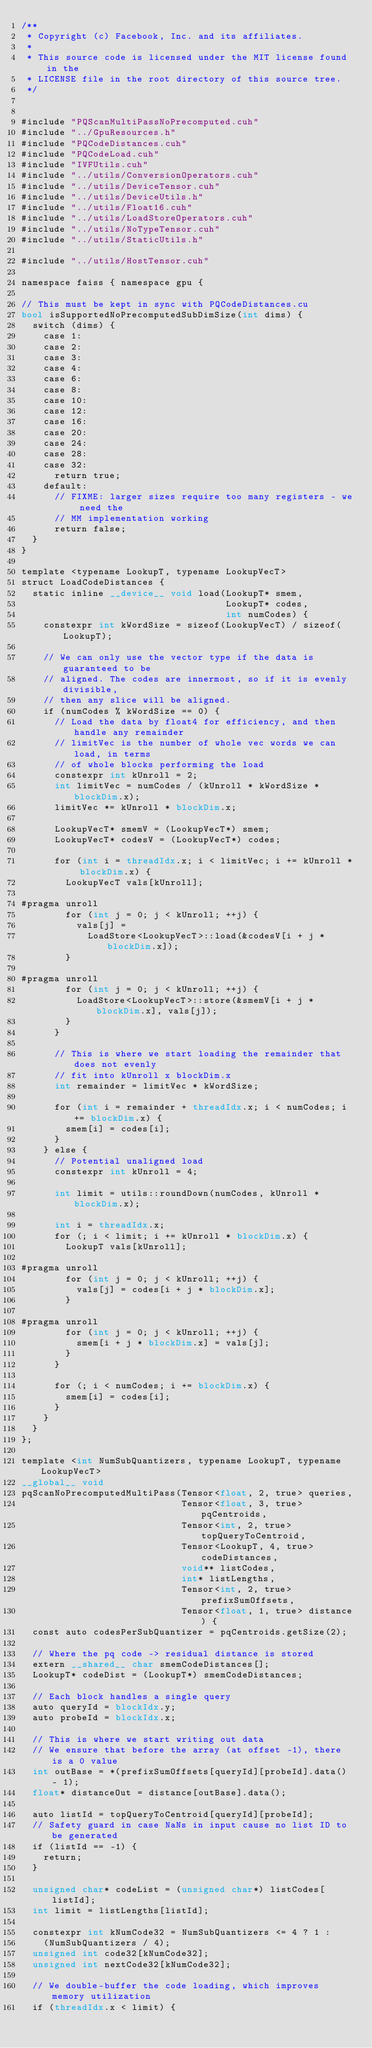Convert code to text. <code><loc_0><loc_0><loc_500><loc_500><_Cuda_>/**
 * Copyright (c) Facebook, Inc. and its affiliates.
 *
 * This source code is licensed under the MIT license found in the
 * LICENSE file in the root directory of this source tree.
 */


#include "PQScanMultiPassNoPrecomputed.cuh"
#include "../GpuResources.h"
#include "PQCodeDistances.cuh"
#include "PQCodeLoad.cuh"
#include "IVFUtils.cuh"
#include "../utils/ConversionOperators.cuh"
#include "../utils/DeviceTensor.cuh"
#include "../utils/DeviceUtils.h"
#include "../utils/Float16.cuh"
#include "../utils/LoadStoreOperators.cuh"
#include "../utils/NoTypeTensor.cuh"
#include "../utils/StaticUtils.h"

#include "../utils/HostTensor.cuh"

namespace faiss { namespace gpu {

// This must be kept in sync with PQCodeDistances.cu
bool isSupportedNoPrecomputedSubDimSize(int dims) {
  switch (dims) {
    case 1:
    case 2:
    case 3:
    case 4:
    case 6:
    case 8:
    case 10:
    case 12:
    case 16:
    case 20:
    case 24:
    case 28:
    case 32:
      return true;
    default:
      // FIXME: larger sizes require too many registers - we need the
      // MM implementation working
      return false;
  }
}

template <typename LookupT, typename LookupVecT>
struct LoadCodeDistances {
  static inline __device__ void load(LookupT* smem,
                                     LookupT* codes,
                                     int numCodes) {
    constexpr int kWordSize = sizeof(LookupVecT) / sizeof(LookupT);

    // We can only use the vector type if the data is guaranteed to be
    // aligned. The codes are innermost, so if it is evenly divisible,
    // then any slice will be aligned.
    if (numCodes % kWordSize == 0) {
      // Load the data by float4 for efficiency, and then handle any remainder
      // limitVec is the number of whole vec words we can load, in terms
      // of whole blocks performing the load
      constexpr int kUnroll = 2;
      int limitVec = numCodes / (kUnroll * kWordSize * blockDim.x);
      limitVec *= kUnroll * blockDim.x;

      LookupVecT* smemV = (LookupVecT*) smem;
      LookupVecT* codesV = (LookupVecT*) codes;

      for (int i = threadIdx.x; i < limitVec; i += kUnroll * blockDim.x) {
        LookupVecT vals[kUnroll];

#pragma unroll
        for (int j = 0; j < kUnroll; ++j) {
          vals[j] =
            LoadStore<LookupVecT>::load(&codesV[i + j * blockDim.x]);
        }

#pragma unroll
        for (int j = 0; j < kUnroll; ++j) {
          LoadStore<LookupVecT>::store(&smemV[i + j * blockDim.x], vals[j]);
        }
      }

      // This is where we start loading the remainder that does not evenly
      // fit into kUnroll x blockDim.x
      int remainder = limitVec * kWordSize;

      for (int i = remainder + threadIdx.x; i < numCodes; i += blockDim.x) {
        smem[i] = codes[i];
      }
    } else {
      // Potential unaligned load
      constexpr int kUnroll = 4;

      int limit = utils::roundDown(numCodes, kUnroll * blockDim.x);

      int i = threadIdx.x;
      for (; i < limit; i += kUnroll * blockDim.x) {
        LookupT vals[kUnroll];

#pragma unroll
        for (int j = 0; j < kUnroll; ++j) {
          vals[j] = codes[i + j * blockDim.x];
        }

#pragma unroll
        for (int j = 0; j < kUnroll; ++j) {
          smem[i + j * blockDim.x] = vals[j];
        }
      }

      for (; i < numCodes; i += blockDim.x) {
        smem[i] = codes[i];
      }
    }
  }
};

template <int NumSubQuantizers, typename LookupT, typename LookupVecT>
__global__ void
pqScanNoPrecomputedMultiPass(Tensor<float, 2, true> queries,
                             Tensor<float, 3, true> pqCentroids,
                             Tensor<int, 2, true> topQueryToCentroid,
                             Tensor<LookupT, 4, true> codeDistances,
                             void** listCodes,
                             int* listLengths,
                             Tensor<int, 2, true> prefixSumOffsets,
                             Tensor<float, 1, true> distance) {
  const auto codesPerSubQuantizer = pqCentroids.getSize(2);

  // Where the pq code -> residual distance is stored
  extern __shared__ char smemCodeDistances[];
  LookupT* codeDist = (LookupT*) smemCodeDistances;

  // Each block handles a single query
  auto queryId = blockIdx.y;
  auto probeId = blockIdx.x;

  // This is where we start writing out data
  // We ensure that before the array (at offset -1), there is a 0 value
  int outBase = *(prefixSumOffsets[queryId][probeId].data() - 1);
  float* distanceOut = distance[outBase].data();

  auto listId = topQueryToCentroid[queryId][probeId];
  // Safety guard in case NaNs in input cause no list ID to be generated
  if (listId == -1) {
    return;
  }

  unsigned char* codeList = (unsigned char*) listCodes[listId];
  int limit = listLengths[listId];

  constexpr int kNumCode32 = NumSubQuantizers <= 4 ? 1 :
    (NumSubQuantizers / 4);
  unsigned int code32[kNumCode32];
  unsigned int nextCode32[kNumCode32];

  // We double-buffer the code loading, which improves memory utilization
  if (threadIdx.x < limit) {</code> 